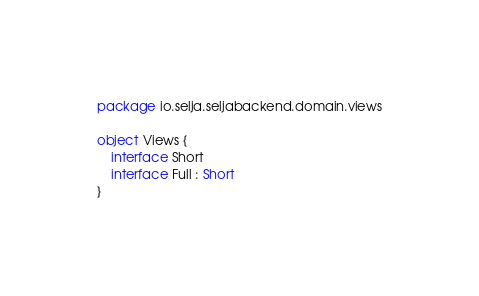Convert code to text. <code><loc_0><loc_0><loc_500><loc_500><_Kotlin_>package io.selja.seljabackend.domain.views

object Views {
    interface Short
    interface Full : Short
}</code> 